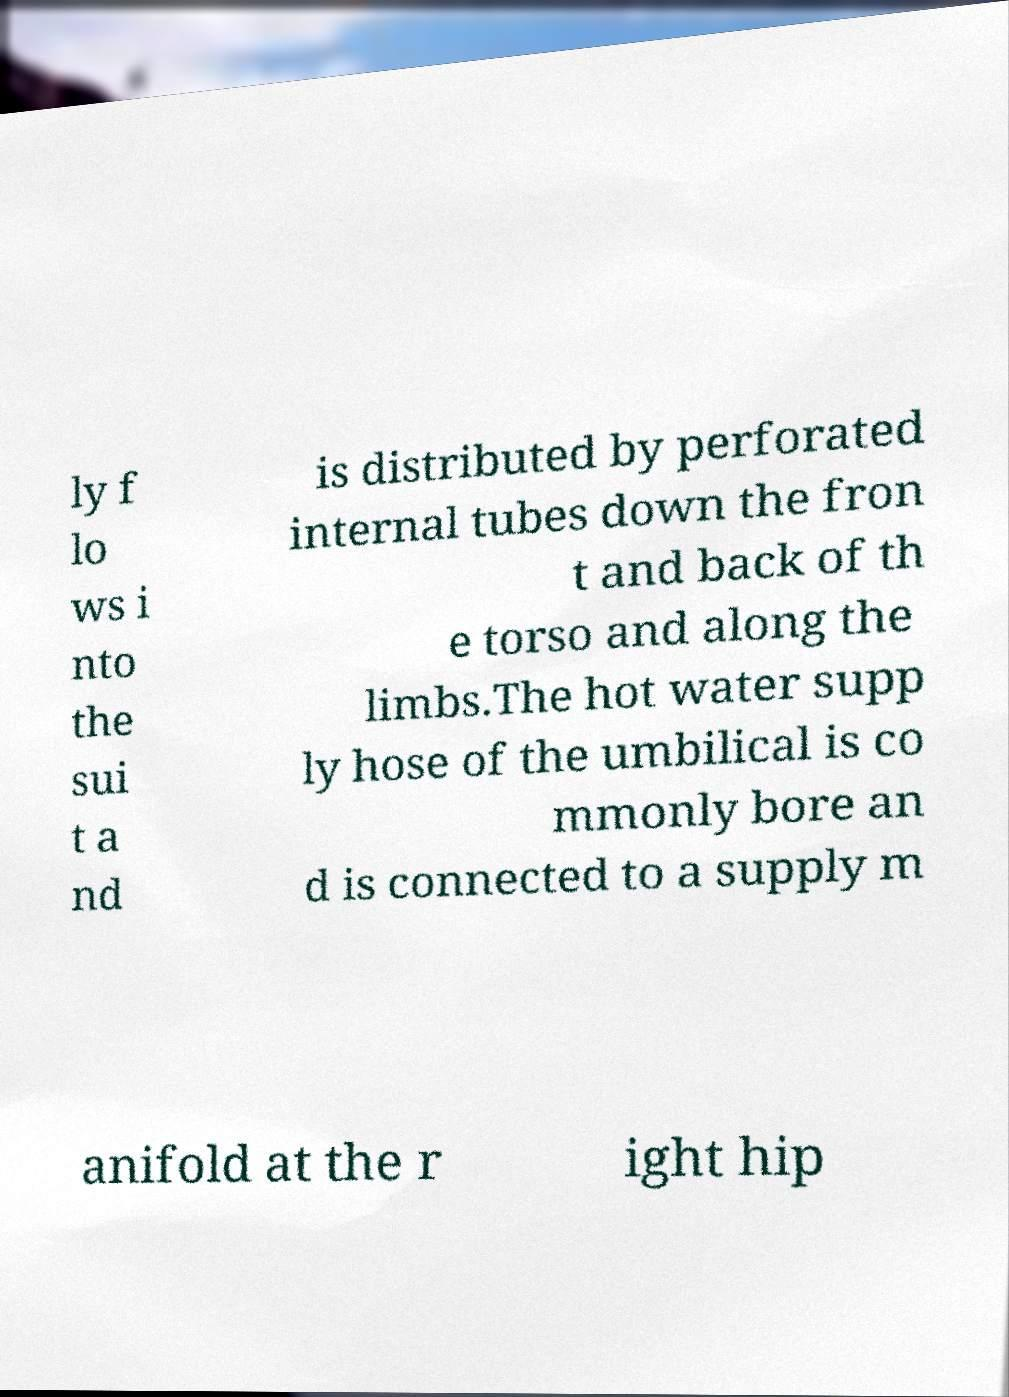Could you extract and type out the text from this image? ly f lo ws i nto the sui t a nd is distributed by perforated internal tubes down the fron t and back of th e torso and along the limbs.The hot water supp ly hose of the umbilical is co mmonly bore an d is connected to a supply m anifold at the r ight hip 